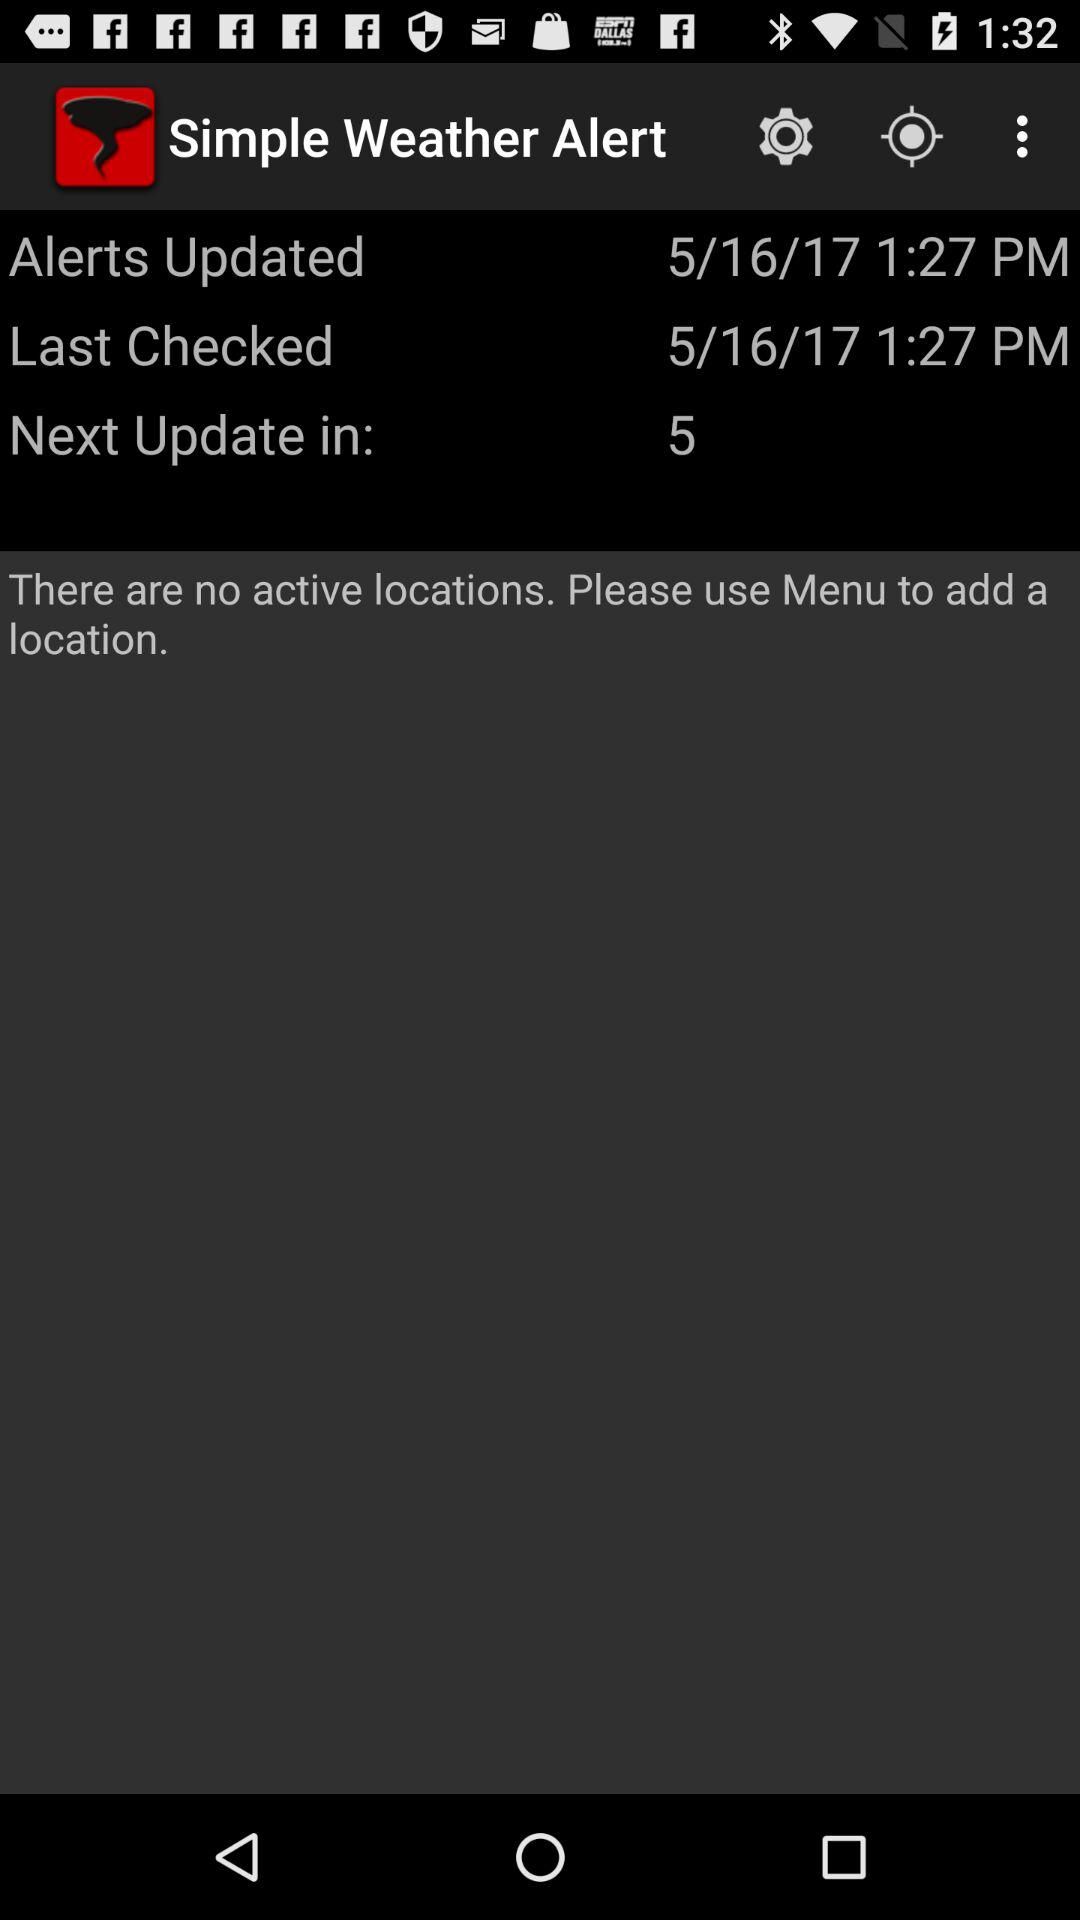At what time was "Simple Weather Alert" last checked? "Simple Weather Alert" was last checked at 1:27 PM. 